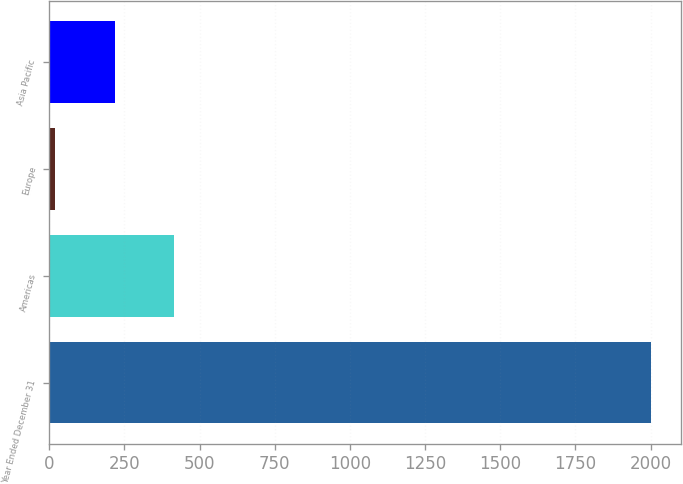<chart> <loc_0><loc_0><loc_500><loc_500><bar_chart><fcel>Year Ended December 31<fcel>Americas<fcel>Europe<fcel>Asia Pacific<nl><fcel>2001<fcel>415.8<fcel>19.5<fcel>217.65<nl></chart> 